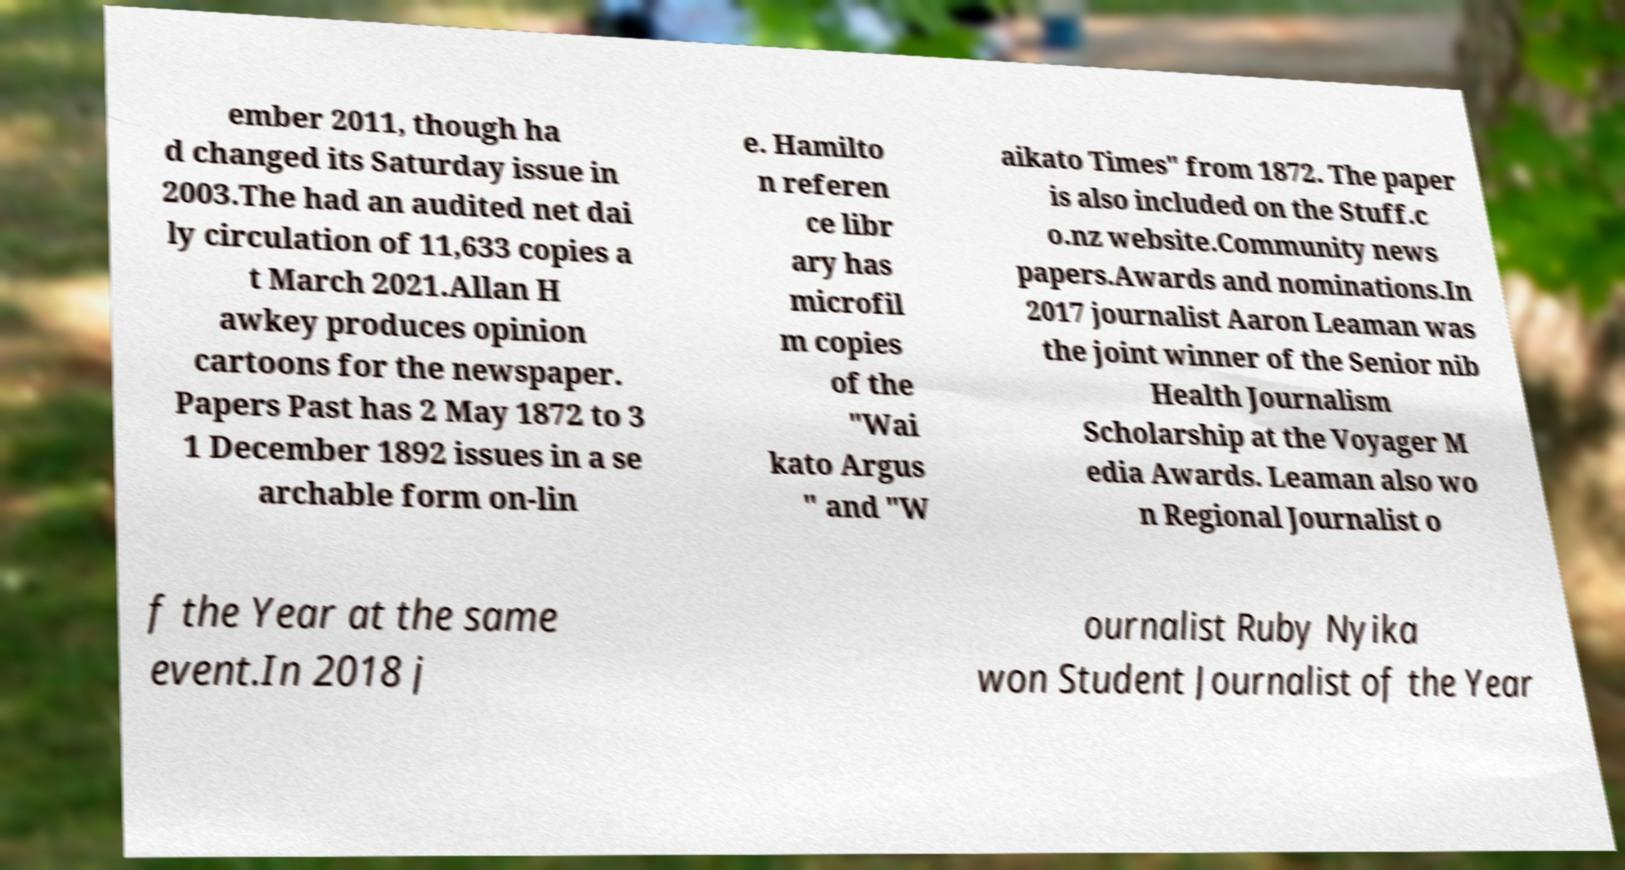Please identify and transcribe the text found in this image. ember 2011, though ha d changed its Saturday issue in 2003.The had an audited net dai ly circulation of 11,633 copies a t March 2021.Allan H awkey produces opinion cartoons for the newspaper. Papers Past has 2 May 1872 to 3 1 December 1892 issues in a se archable form on-lin e. Hamilto n referen ce libr ary has microfil m copies of the "Wai kato Argus " and "W aikato Times" from 1872. The paper is also included on the Stuff.c o.nz website.Community news papers.Awards and nominations.In 2017 journalist Aaron Leaman was the joint winner of the Senior nib Health Journalism Scholarship at the Voyager M edia Awards. Leaman also wo n Regional Journalist o f the Year at the same event.In 2018 j ournalist Ruby Nyika won Student Journalist of the Year 